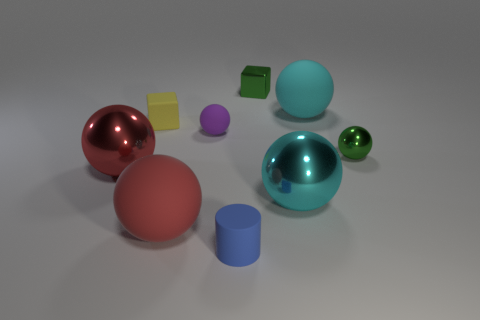How many cyan spheres must be subtracted to get 1 cyan spheres? 1 Subtract all big red spheres. How many spheres are left? 4 Add 1 big metal objects. How many objects exist? 10 Subtract all purple spheres. How many spheres are left? 5 Subtract all spheres. How many objects are left? 3 Subtract all brown cubes. How many purple balls are left? 1 Subtract all small yellow objects. Subtract all red shiny spheres. How many objects are left? 7 Add 8 cyan spheres. How many cyan spheres are left? 10 Add 8 tiny cyan objects. How many tiny cyan objects exist? 8 Subtract 0 brown cylinders. How many objects are left? 9 